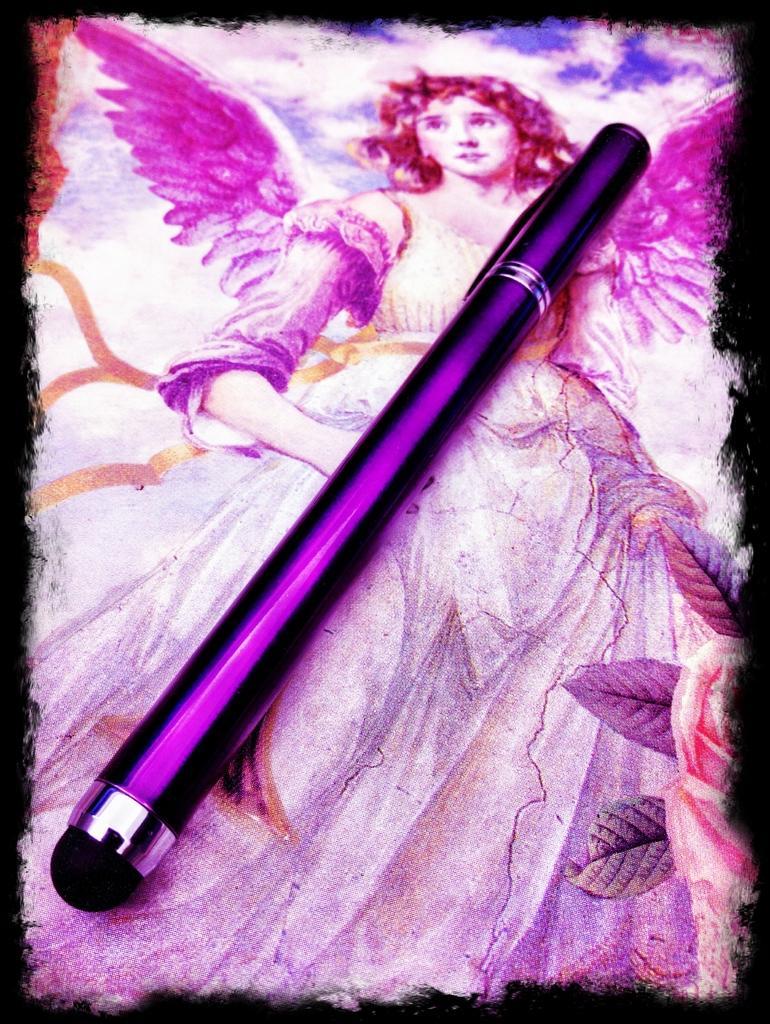What is the main subject of the image? There is a painting in the image. What is depicted in the painting? The painting depicts an angel. Are there any objects or elements within the painting? Yes, there is a pen in the painting. Where is the cat located in the image? There is no cat present in the image; it only features a painting of an angel with a pen. Is the angel in the painting attacking anyone? The painting does not depict any attack or aggressive behavior; it simply shows an angel with a pen. 